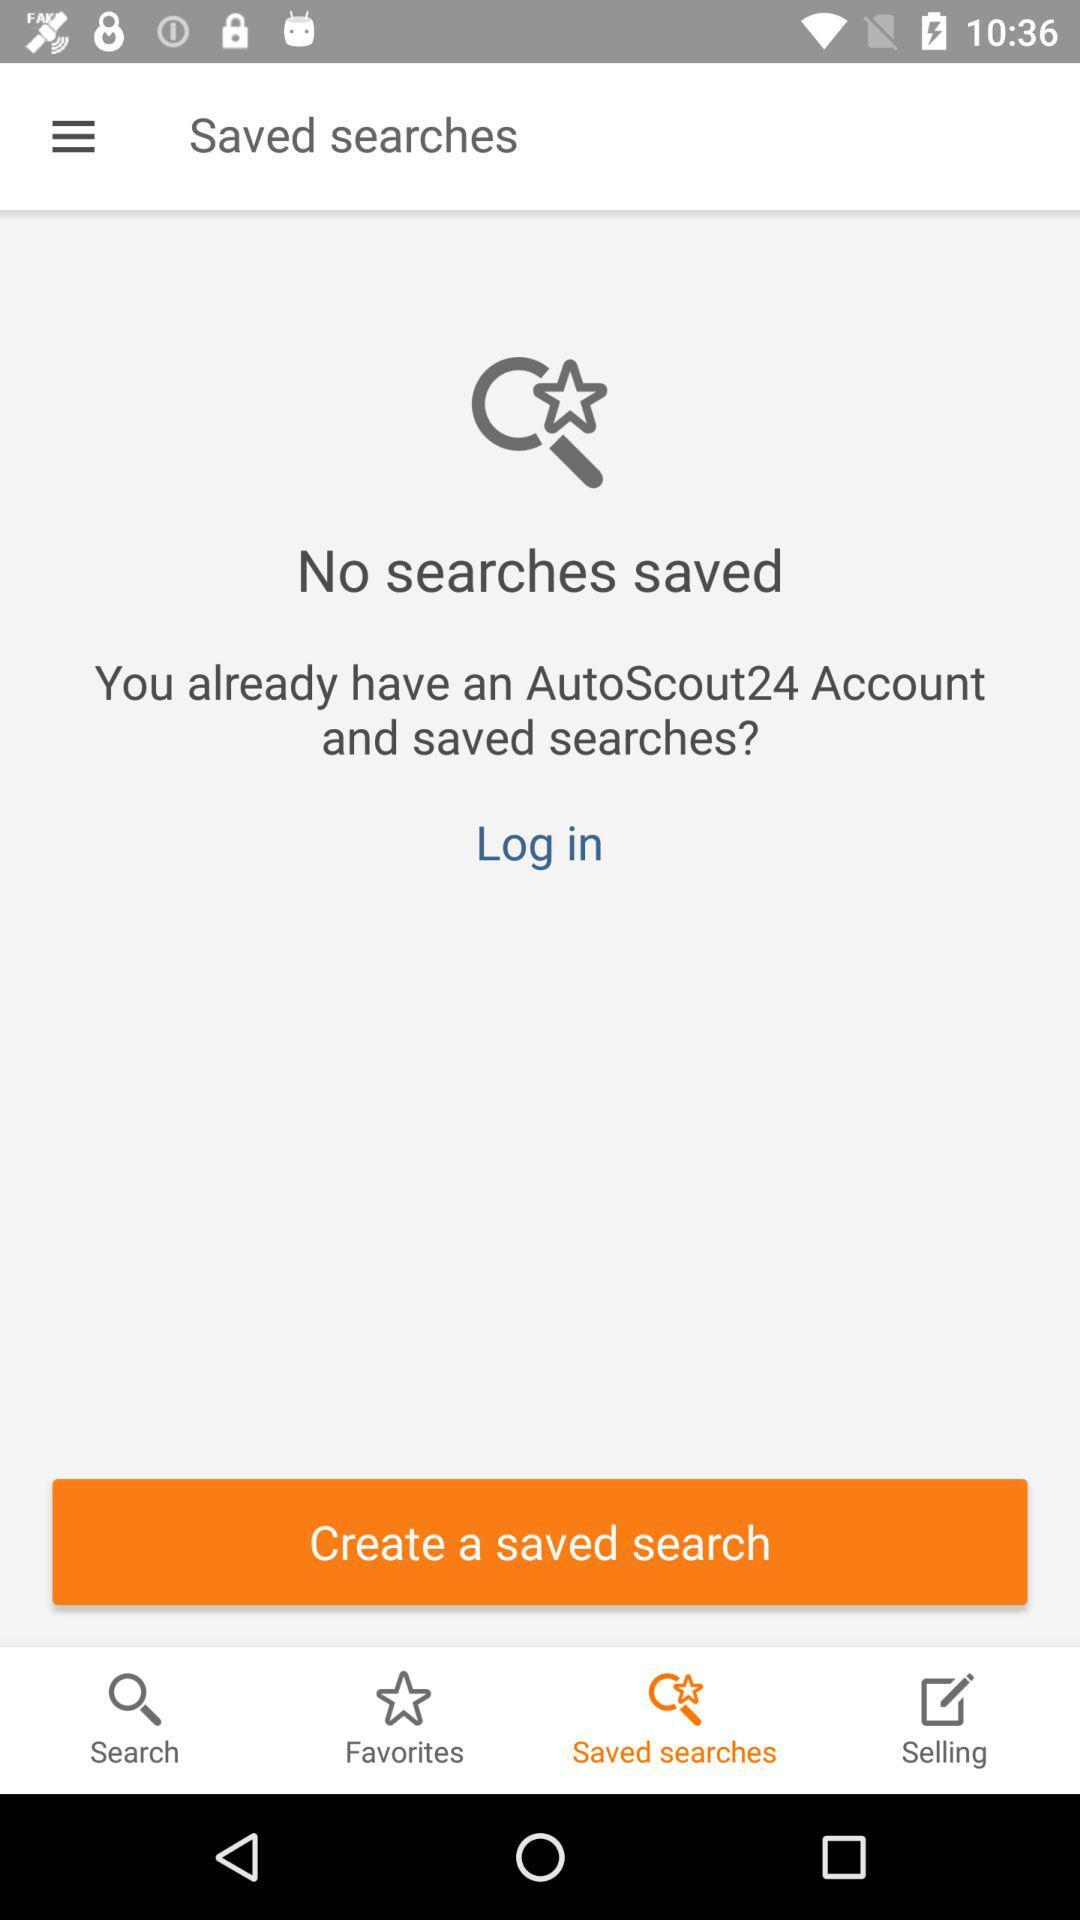Which tab is selected? The selected tab is "Saved searches". 